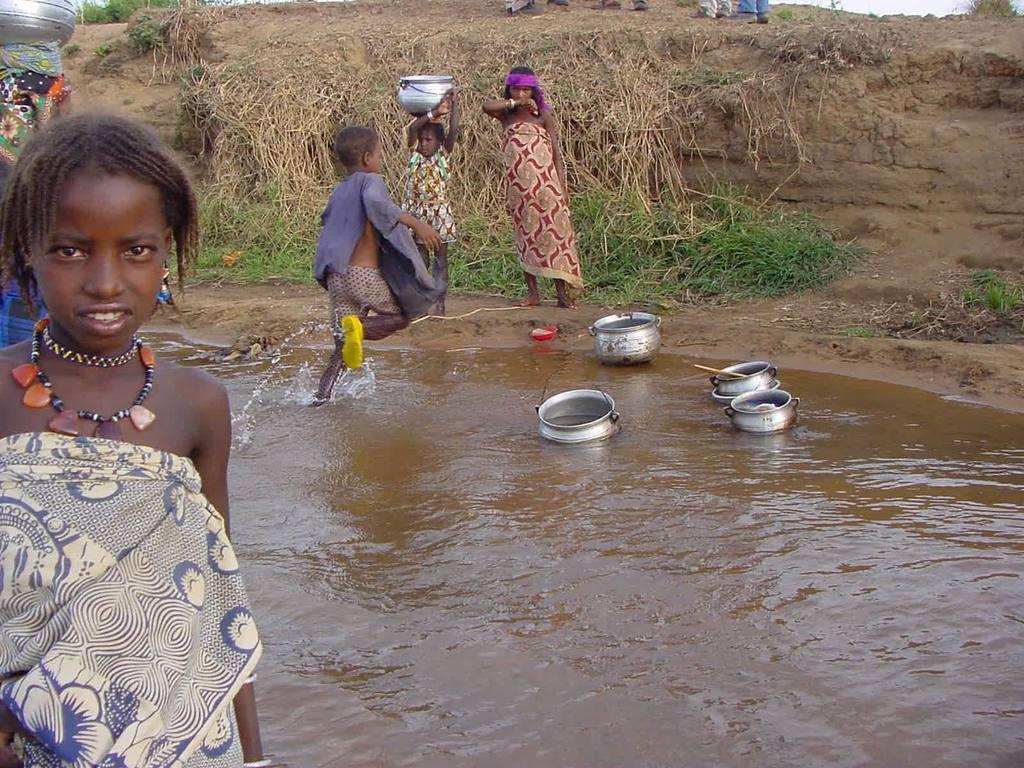How many people are in the image? There are four persons standing in the image. What are two of the persons doing in the image? Two of the persons are holding objects. What can be seen floating on the water in the image? There are utensils on the water in the image. What type of natural environment is visible in the background of the image? There is grass visible in the background of the image. Are there any fairies visible in the image? No, there are no fairies present in the image. What type of work are the persons engaged in within the image? The facts provided do not give any information about the type of work the persons might be engaged in. 